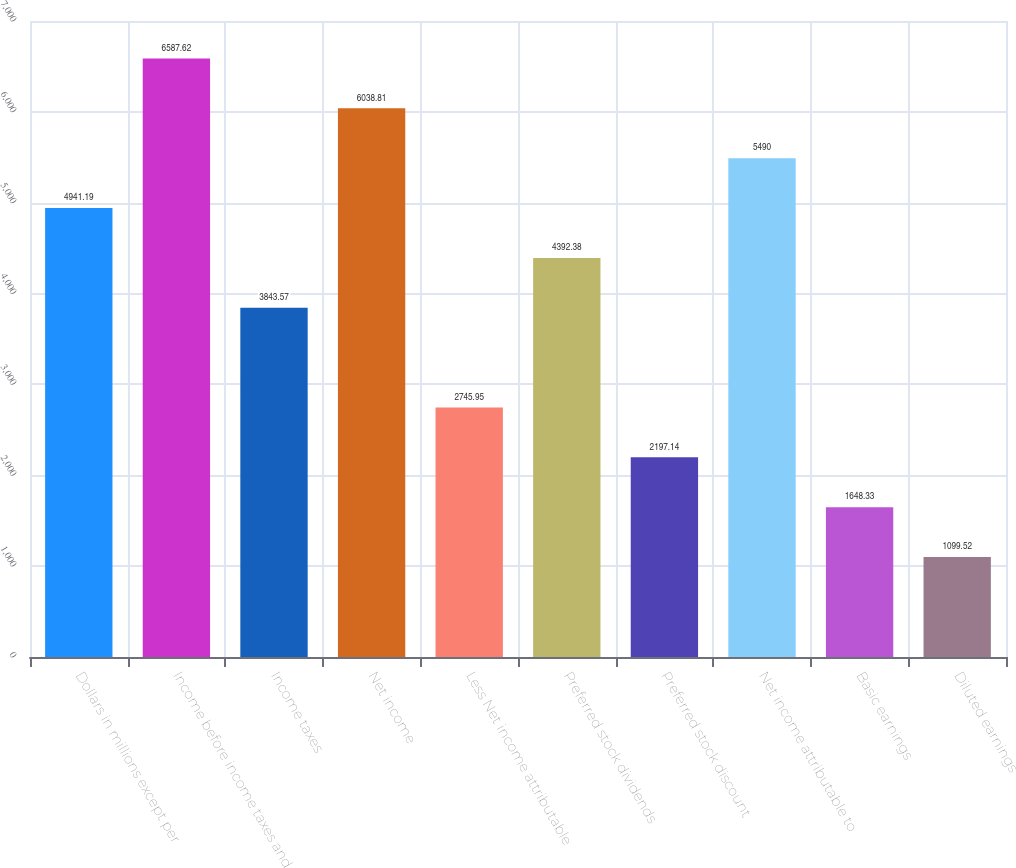Convert chart to OTSL. <chart><loc_0><loc_0><loc_500><loc_500><bar_chart><fcel>Dollars in millions except per<fcel>Income before income taxes and<fcel>Income taxes<fcel>Net income<fcel>Less Net income attributable<fcel>Preferred stock dividends<fcel>Preferred stock discount<fcel>Net income attributable to<fcel>Basic earnings<fcel>Diluted earnings<nl><fcel>4941.19<fcel>6587.62<fcel>3843.57<fcel>6038.81<fcel>2745.95<fcel>4392.38<fcel>2197.14<fcel>5490<fcel>1648.33<fcel>1099.52<nl></chart> 